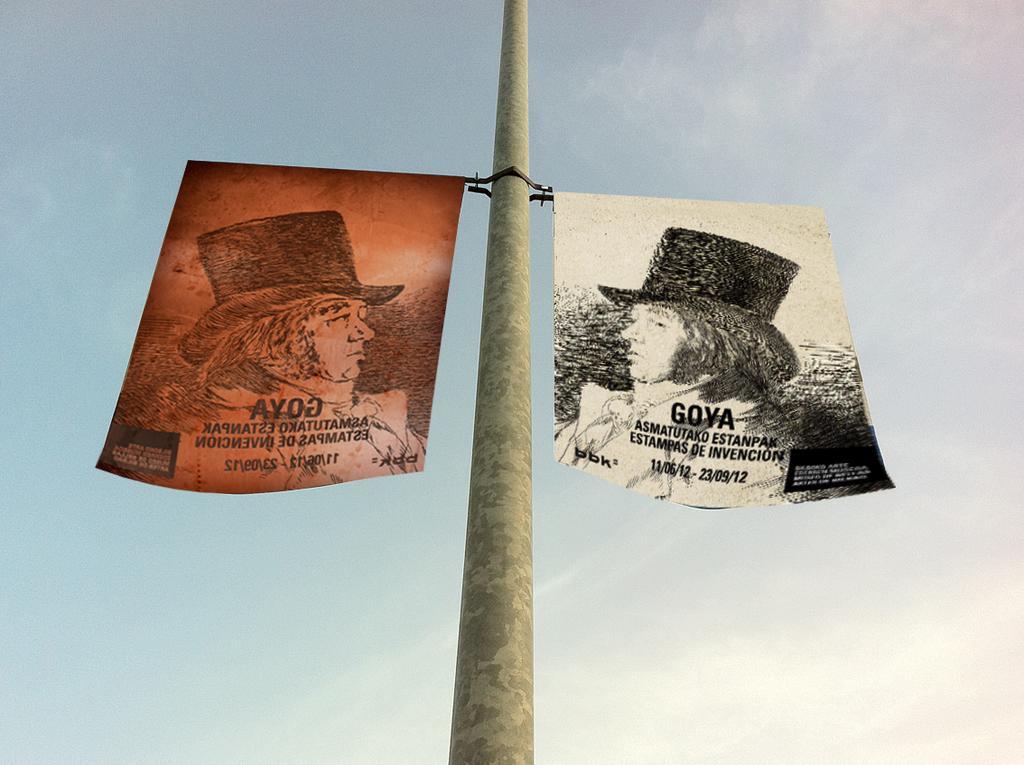Could you give a brief overview of what you see in this image? In this image we can see two pictures hanged to a pole. On the backside we can see the sky which looks cloudy. 